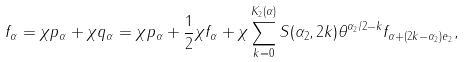Convert formula to latex. <formula><loc_0><loc_0><loc_500><loc_500>f _ { \alpha } = \chi p _ { \alpha } + \chi q _ { \alpha } = \chi p _ { \alpha } + \frac { 1 } { 2 } \chi f _ { \alpha } + \chi \sum _ { k = 0 } ^ { K _ { 2 } ( \alpha ) } S ( \alpha _ { 2 } , 2 k ) \theta ^ { \alpha _ { 2 } / 2 - k } f _ { \alpha + ( 2 k - \alpha _ { 2 } ) e _ { 2 } } ,</formula> 